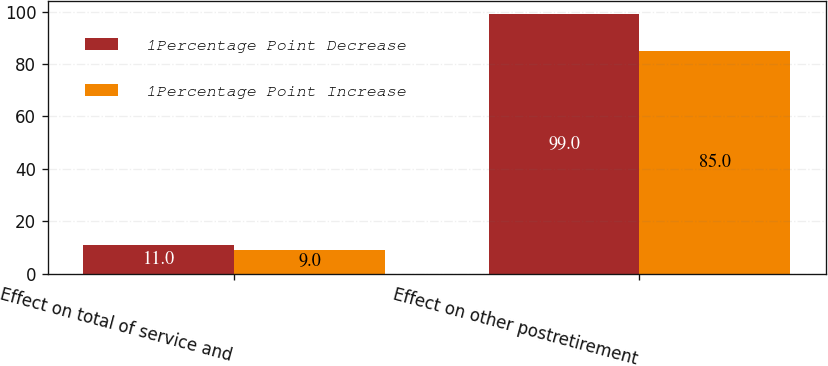Convert chart. <chart><loc_0><loc_0><loc_500><loc_500><stacked_bar_chart><ecel><fcel>Effect on total of service and<fcel>Effect on other postretirement<nl><fcel>1Percentage Point Decrease<fcel>11<fcel>99<nl><fcel>1Percentage Point Increase<fcel>9<fcel>85<nl></chart> 